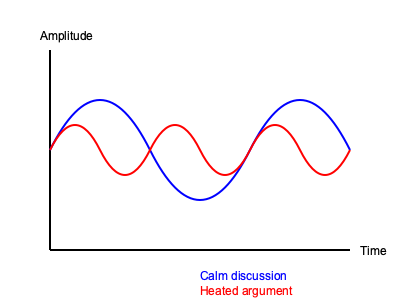Based on the sound wave patterns shown in the graph, which type of argument is likely to have a higher frequency and why might this be significant in understanding the emotional intensity of the conversation? To answer this question, let's analyze the graph step-by-step:

1. The graph shows two sound wave patterns: one in blue (labeled "Calm discussion") and one in red (labeled "Heated argument").

2. Frequency in sound waves is represented by how many cycles occur in a given time period. In this graph, we can see that:
   a. The blue wave (calm discussion) has fewer cycles within the same time frame.
   b. The red wave (heated argument) has more cycles within the same time frame.

3. Therefore, the heated argument has a higher frequency.

4. The significance of this higher frequency in understanding emotional intensity:
   a. Higher frequency sounds are generally perceived as higher in pitch.
   b. In human speech, higher pitch is often associated with increased emotional arousal or stress.
   c. During heated arguments, people tend to speak faster and with more tension in their vocal cords, resulting in higher-pitched voices.

5. The amplitude (height of the waves) also differs:
   a. The blue wave has larger, smoother amplitude changes.
   b. The red wave has shorter, more frequent amplitude changes.

6. This amplitude difference further supports the interpretation of emotional intensity:
   a. Rapid changes in amplitude can indicate more abrupt changes in volume or emphasis.
   b. This pattern is typical in heated arguments where people may frequently raise their voices or speak more forcefully.

In conclusion, the higher frequency of the heated argument sound wave is significant because it reflects the increased emotional intensity and stress typically present in such conversations.
Answer: Heated argument; higher frequency indicates increased emotional intensity and stress in speech. 